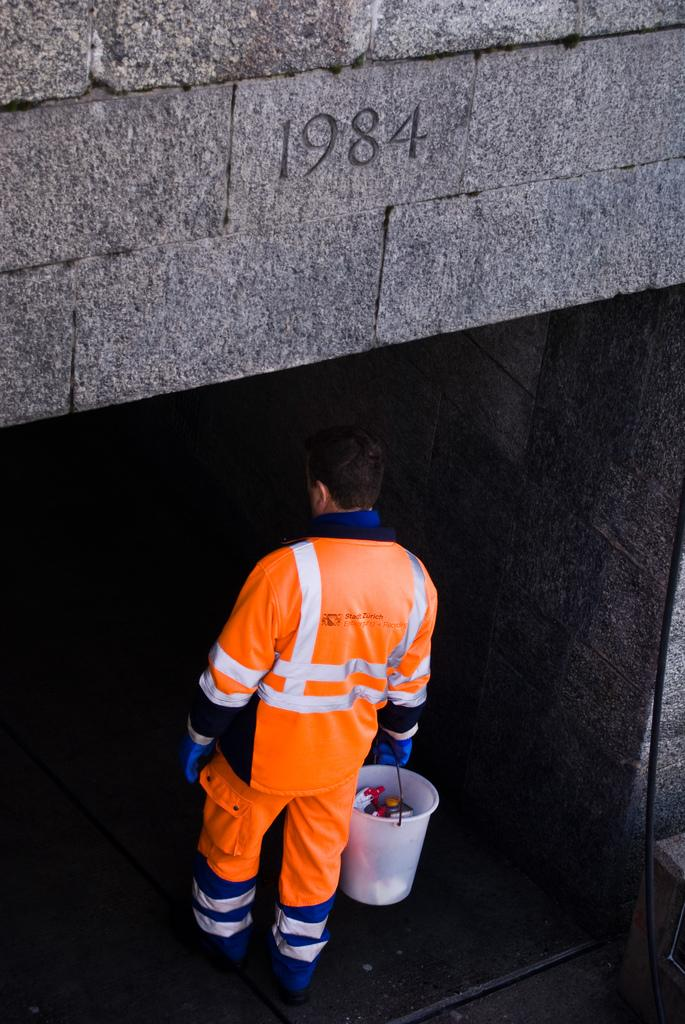<image>
Write a terse but informative summary of the picture. A man in an orange Stadt Zurich uniform is walking into a tunnel that says 1984. 